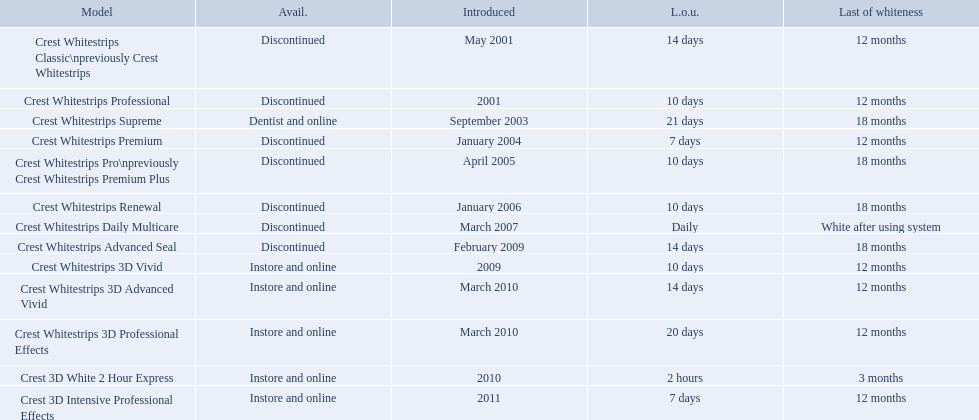Which models are still available? Crest Whitestrips Supreme, Crest Whitestrips 3D Vivid, Crest Whitestrips 3D Advanced Vivid, Crest Whitestrips 3D Professional Effects, Crest 3D White 2 Hour Express, Crest 3D Intensive Professional Effects. Of those, which were introduced prior to 2011? Crest Whitestrips Supreme, Crest Whitestrips 3D Vivid, Crest Whitestrips 3D Advanced Vivid, Crest Whitestrips 3D Professional Effects, Crest 3D White 2 Hour Express. Among those models, which ones had to be used at least 14 days? Crest Whitestrips Supreme, Crest Whitestrips 3D Advanced Vivid, Crest Whitestrips 3D Professional Effects. Which of those lasted longer than 12 months? Crest Whitestrips Supreme. What are all the models? Crest Whitestrips Classic\npreviously Crest Whitestrips, Crest Whitestrips Professional, Crest Whitestrips Supreme, Crest Whitestrips Premium, Crest Whitestrips Pro\npreviously Crest Whitestrips Premium Plus, Crest Whitestrips Renewal, Crest Whitestrips Daily Multicare, Crest Whitestrips Advanced Seal, Crest Whitestrips 3D Vivid, Crest Whitestrips 3D Advanced Vivid, Crest Whitestrips 3D Professional Effects, Crest 3D White 2 Hour Express, Crest 3D Intensive Professional Effects. Of these, for which can a ratio be calculated for 'length of use' to 'last of whiteness'? Crest Whitestrips Classic\npreviously Crest Whitestrips, Crest Whitestrips Professional, Crest Whitestrips Supreme, Crest Whitestrips Premium, Crest Whitestrips Pro\npreviously Crest Whitestrips Premium Plus, Crest Whitestrips Renewal, Crest Whitestrips Advanced Seal, Crest Whitestrips 3D Vivid, Crest Whitestrips 3D Advanced Vivid, Crest Whitestrips 3D Professional Effects, Crest 3D White 2 Hour Express, Crest 3D Intensive Professional Effects. Which has the highest ratio? Crest Whitestrips Supreme. When was crest whitestrips 3d advanced vivid introduced? March 2010. What other product was introduced in march 2010? Crest Whitestrips 3D Professional Effects. 